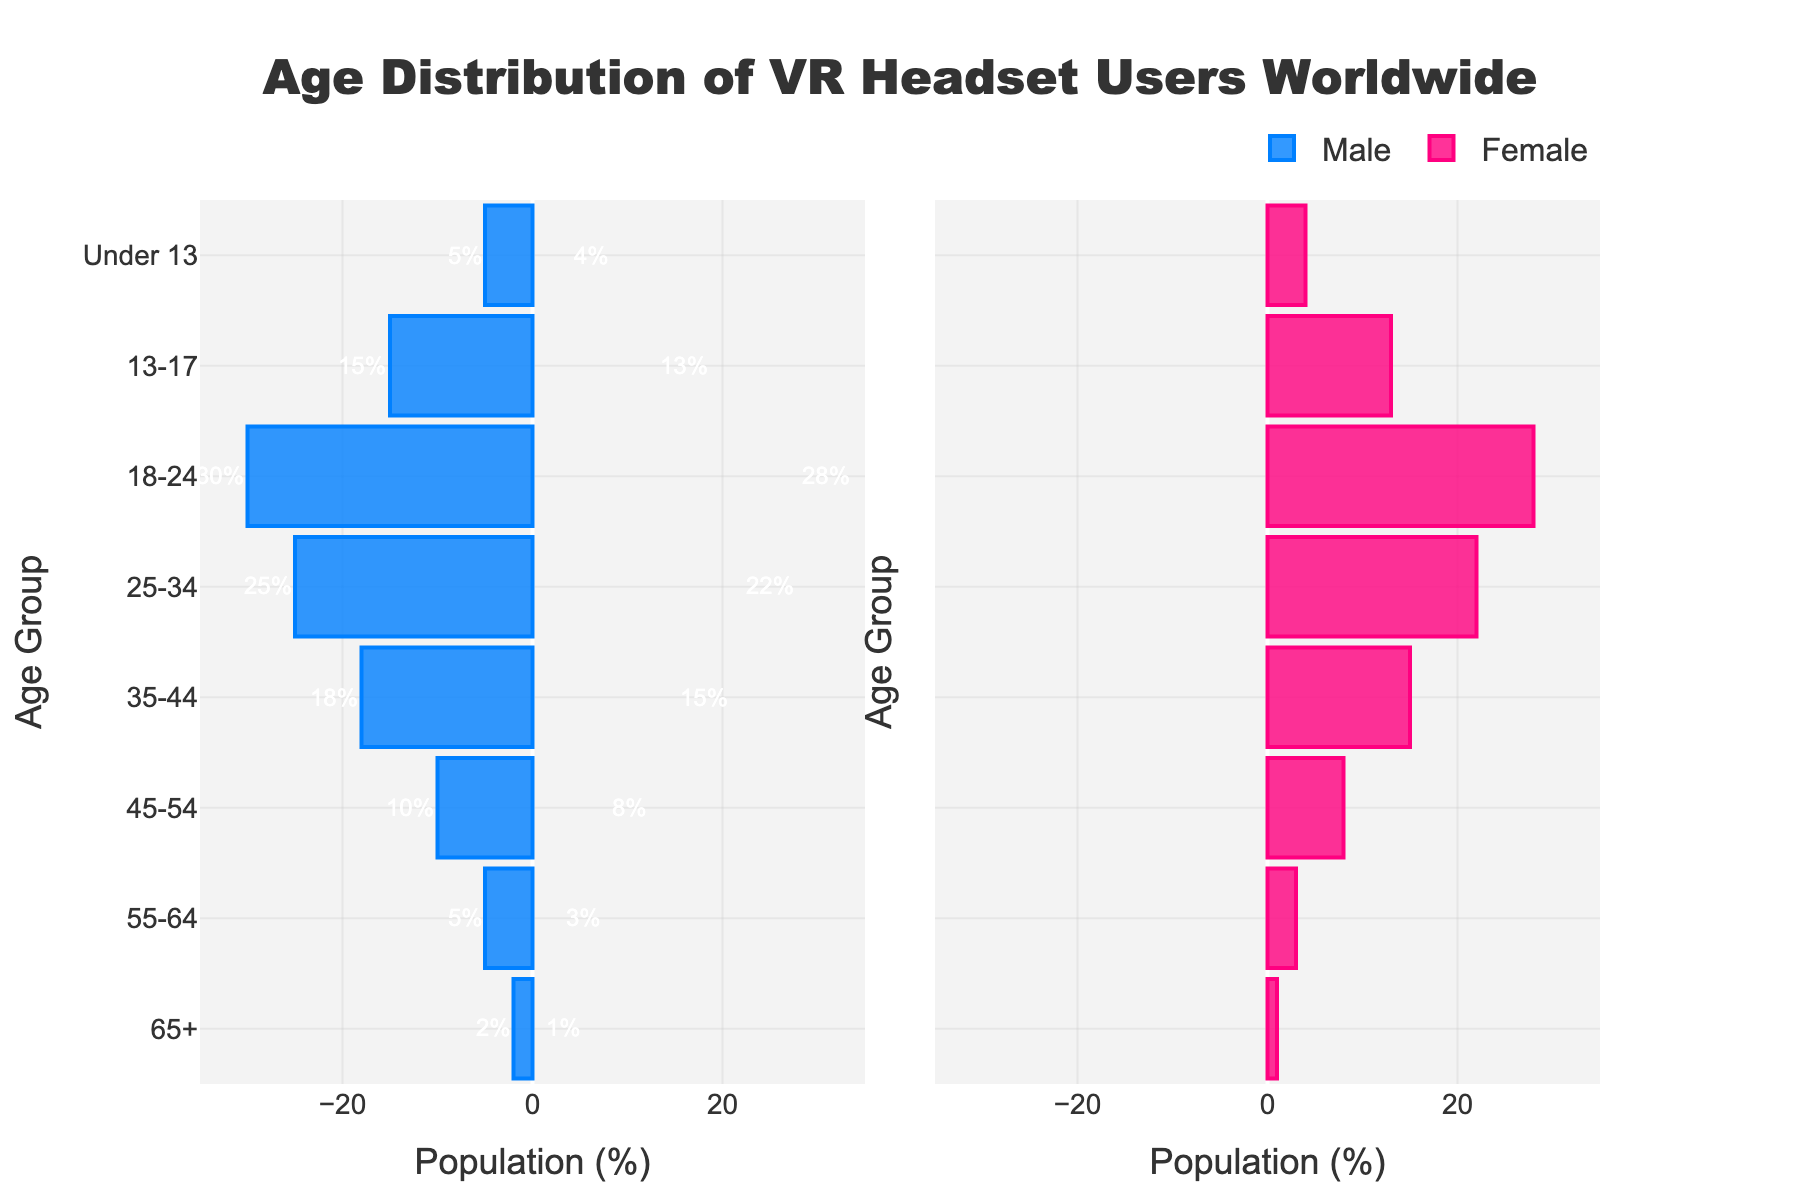what is the age group with the highest percentage of male VR users? The age group with the highest percentage of male VR users can be identified by finding the bar with the longest negative length on the male (left) side of the plot. The '18-24' age group has the longest bar on the male side, indicating the highest percentage.
Answer: 18-24 which age group has the most balanced distribution between male and female users? To determine the most balanced distribution, we look for the age group where the male and female bars are closest in length. The '18-24' age group has values of 30% for males and 28% for females, which are quite close.
Answer: 18-24 what is the total percentage of VR users under the age of 18? Add the percentages of both male and female users from the 'Under 13' and '13-17' age groups. For 'Under 13', (5% males + 4% females) = 9%, and for '13-17', (15% males + 13% females) = 28%. Summing up, 9% + 28% = 37%.
Answer: 37% how does the percentage of male users in the '25-34' age group compare to that of the '45-54' age group? The '25-34' age group has 25% male users, while the '45-54' age group has 10% male users. Subtracting the smaller percentage from the larger gives us the difference: 25% - 10% = 15%. Therefore, the percentage of male users in '25-34' is 15% higher than in '45-54'.
Answer: 15% higher what percentage of female VR users are 55 and older? Add the percentages of female users from the '55-64' and '65+' age groups. For '55-64', it's 3%, and for '65+', it's 1%. Summing these, 3% + 1% = 4%.
Answer: 4% which gender has a higher percentage in the '35-44' age group? Compare the lengths of the bars for males and females in the '35-44' age group. Males have 18%, and females have 15%. Since 18% is greater than 15%, males have a higher percentage.
Answer: males what is the average percentage of male users in the two youngest age groups? The youngest age groups are 'Under 13' and '13-17'. For 'Under 13', males are 5%, and for '13-17', males are 15%. The average is calculated as (5% + 15%) / 2 = 10%.
Answer: 10% is the percentage of female VR users decreasing as age increases? Compare the percentages of female users across age groups from youngest to oldest: 'Under 13' (4%), '13-17' (13%), '18-24' (28%), '25-34' (22%), '35-44' (15%), '45-54' (8%), '55-64' (3%), and '65+' (1%). The pattern does not show a consistent decrease with age.
Answer: no what is the combined percentage of VR users aged '65+'? Add the percentages of both male and female users in the '65+' age group. Males are 2%, and females are 1%. Summing these, 2% + 1% = 3%.
Answer: 3% which age group has the largest gender gap in VR users? Calculate the absolute difference between male and female percentages for each age group. The largest difference is in the '25-34' age group, where males are 25% and females are 22%, resulting in a 3% difference. However, examining further, '45-54' has males at 10% and females at 8%, just a 2% gap, so '25-34' has the largest gender gap.
Answer: 25-34 